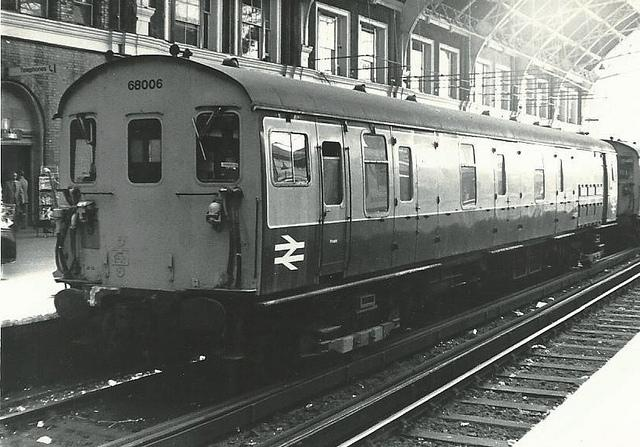What type of building is this?

Choices:
A) hospital
B) school
C) library
D) station station 